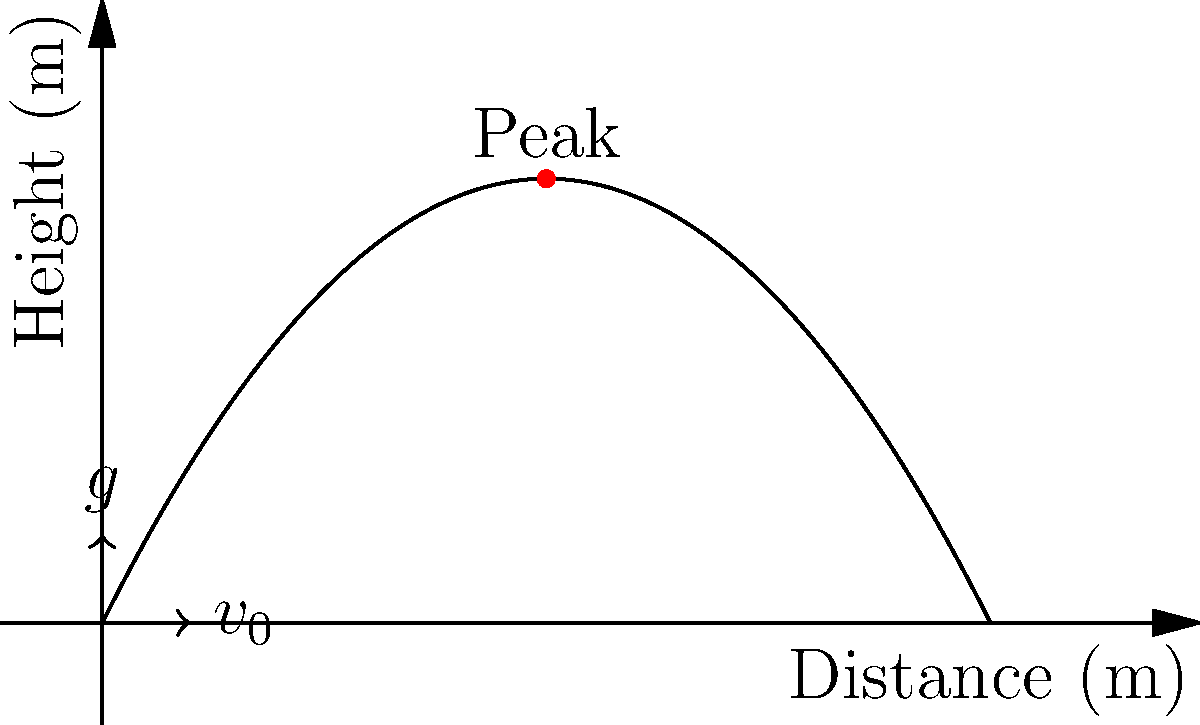As an event promoter planning a grand finale for your next party, you're considering using a confetti cannon. The trajectory of the confetti is shown in the graph above. If the initial velocity ($v_0$) of the confetti is 10 m/s and it reaches a maximum height of 5 meters, what is the time taken for the confetti to reach its highest point? Let's approach this step-by-step:

1) In projectile motion, the vertical component of velocity ($v_y$) at the highest point is zero.

2) We can use the equation: $v_y = v_0 \sin \theta - gt$
   Where $\theta$ is the launch angle, $g$ is the acceleration due to gravity (9.8 m/s²), and $t$ is the time to reach the highest point.

3) At the highest point, $v_y = 0$, so:
   $0 = v_0 \sin \theta - gt$

4) Rearranging this equation:
   $t = \frac{v_0 \sin \theta}{g}$

5) We don't know $\theta$, but we can find $\sin \theta$ using the maximum height:
   $h = \frac{(v_0 \sin \theta)^2}{2g}$

6) Rearranging this equation:
   $\sin \theta = \sqrt{\frac{2gh}{v_0^2}}$

7) Substituting the values ($h = 5$ m, $v_0 = 10$ m/s, $g = 9.8$ m/s²):
   $\sin \theta = \sqrt{\frac{2 * 9.8 * 5}{10^2}} = \sqrt{0.98} = 0.99$

8) Now we can find $t$:
   $t = \frac{10 * 0.99}{9.8} = 1.01$ seconds

Therefore, the confetti takes approximately 1.01 seconds to reach its highest point.
Answer: 1.01 seconds 